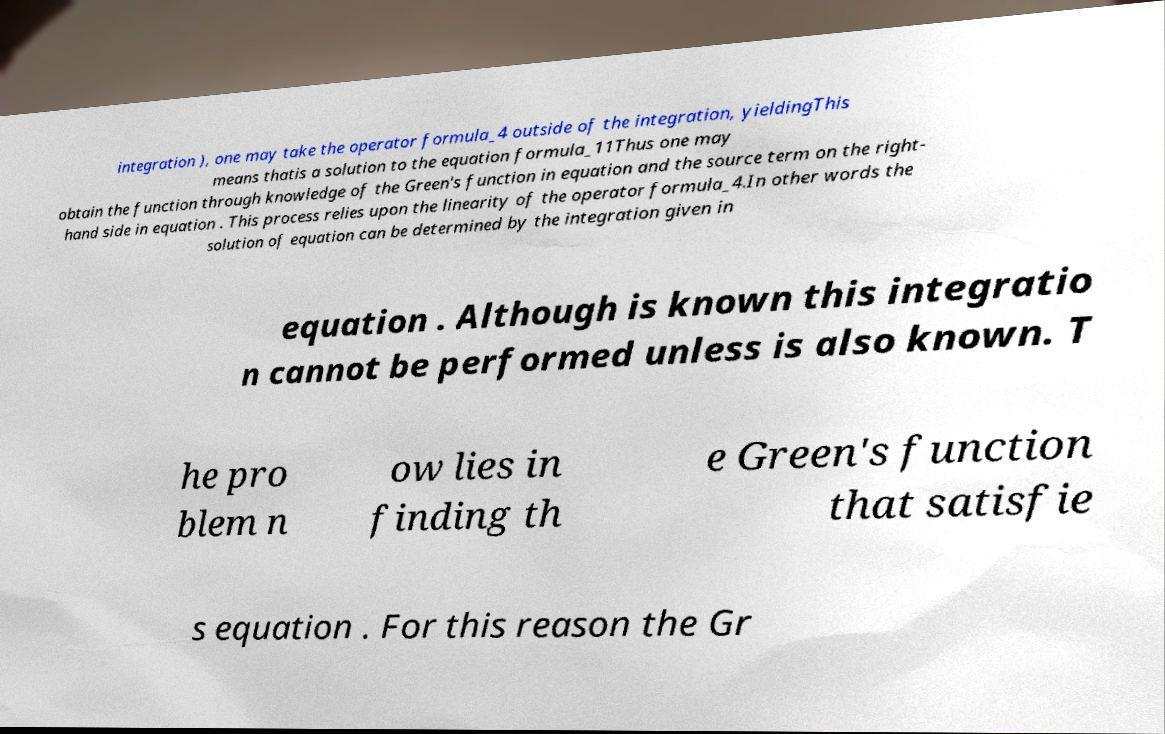Please read and relay the text visible in this image. What does it say? integration ), one may take the operator formula_4 outside of the integration, yieldingThis means thatis a solution to the equation formula_11Thus one may obtain the function through knowledge of the Green's function in equation and the source term on the right- hand side in equation . This process relies upon the linearity of the operator formula_4.In other words the solution of equation can be determined by the integration given in equation . Although is known this integratio n cannot be performed unless is also known. T he pro blem n ow lies in finding th e Green's function that satisfie s equation . For this reason the Gr 